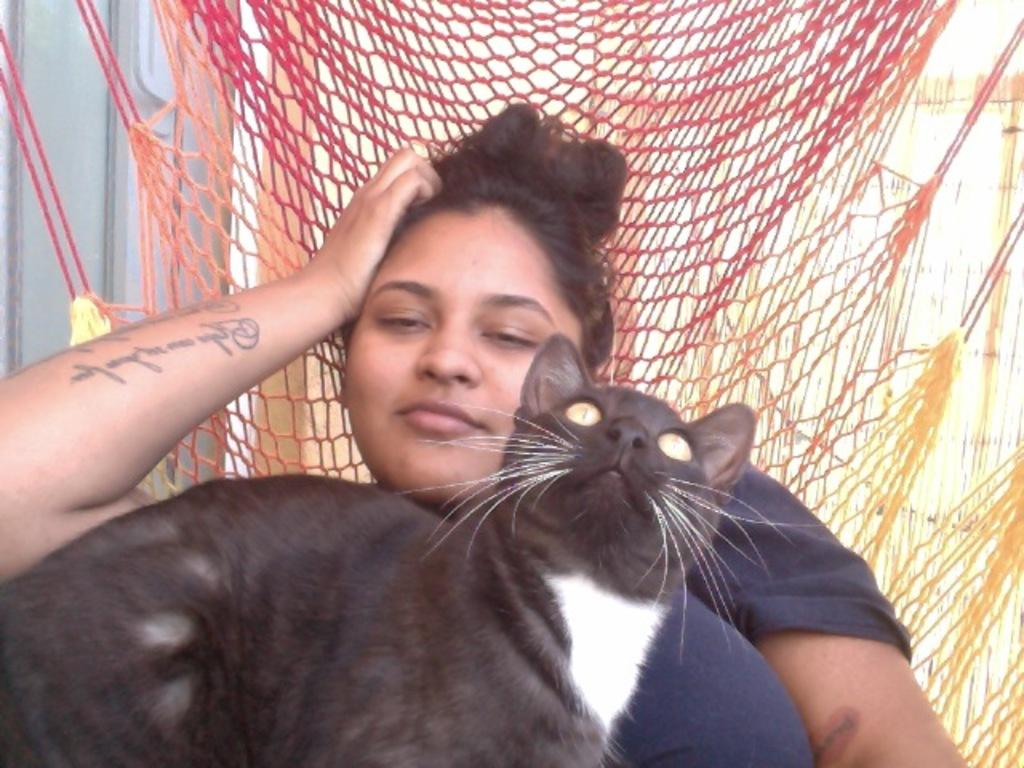Who is present in the image? There is a woman in the image. What is the woman doing in the image? The woman is sitting in a net chair. Is there any other living creature in the image? Yes, a cat is sitting on the woman. What can be seen behind the woman? There is a wall behind the woman. What type of property does the woman own in the image? There is no information about the woman's property in the image. Can you tell me how many times the cat bit the woman in the image? There is no indication of the cat biting the woman in the image. 